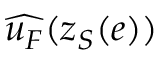<formula> <loc_0><loc_0><loc_500><loc_500>\widehat { u _ { F } } ( z _ { S } ( e ) )</formula> 